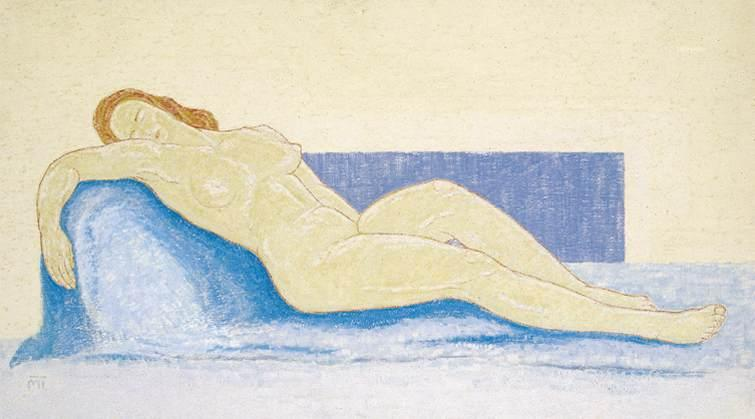Can you describe how the style of the artwork influences the perception of the subject? The impressionistic style of the artwork, characterized by its loose and expressive pastel strokes, imparts a soft and almost ethereal quality to the scene. This technique allows for a fluid interpretation of the woman's form, emphasizing the play of light and shadow and the overall impression of a moment captured in time. The gentle rendering of her features and the environment suggests a dreamlike state, inviting the viewer to engage with the artwork on a more emotional and personal level. Does the style contribute to a sense of motion or stillness? The style contributes predominantly to a sense of stillness. The soft brushwork and mellow color choices create a serene tableau, capturing a snapshot where time seems to pause. The relaxed posture of the figure and the diffused edges blur the lines between the subject and her surroundings, reinforcing the stillness and quietude inherent in the painting. 